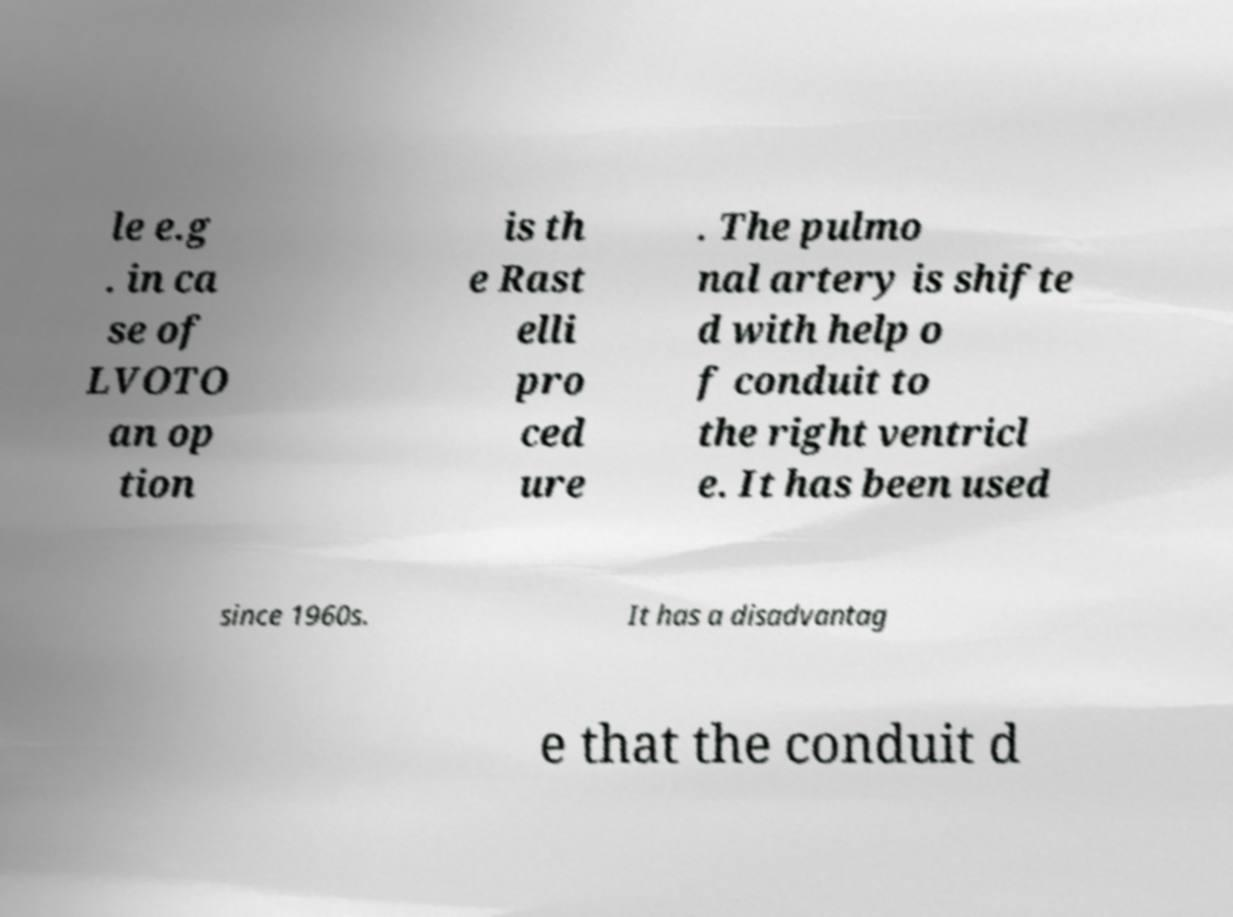I need the written content from this picture converted into text. Can you do that? le e.g . in ca se of LVOTO an op tion is th e Rast elli pro ced ure . The pulmo nal artery is shifte d with help o f conduit to the right ventricl e. It has been used since 1960s. It has a disadvantag e that the conduit d 